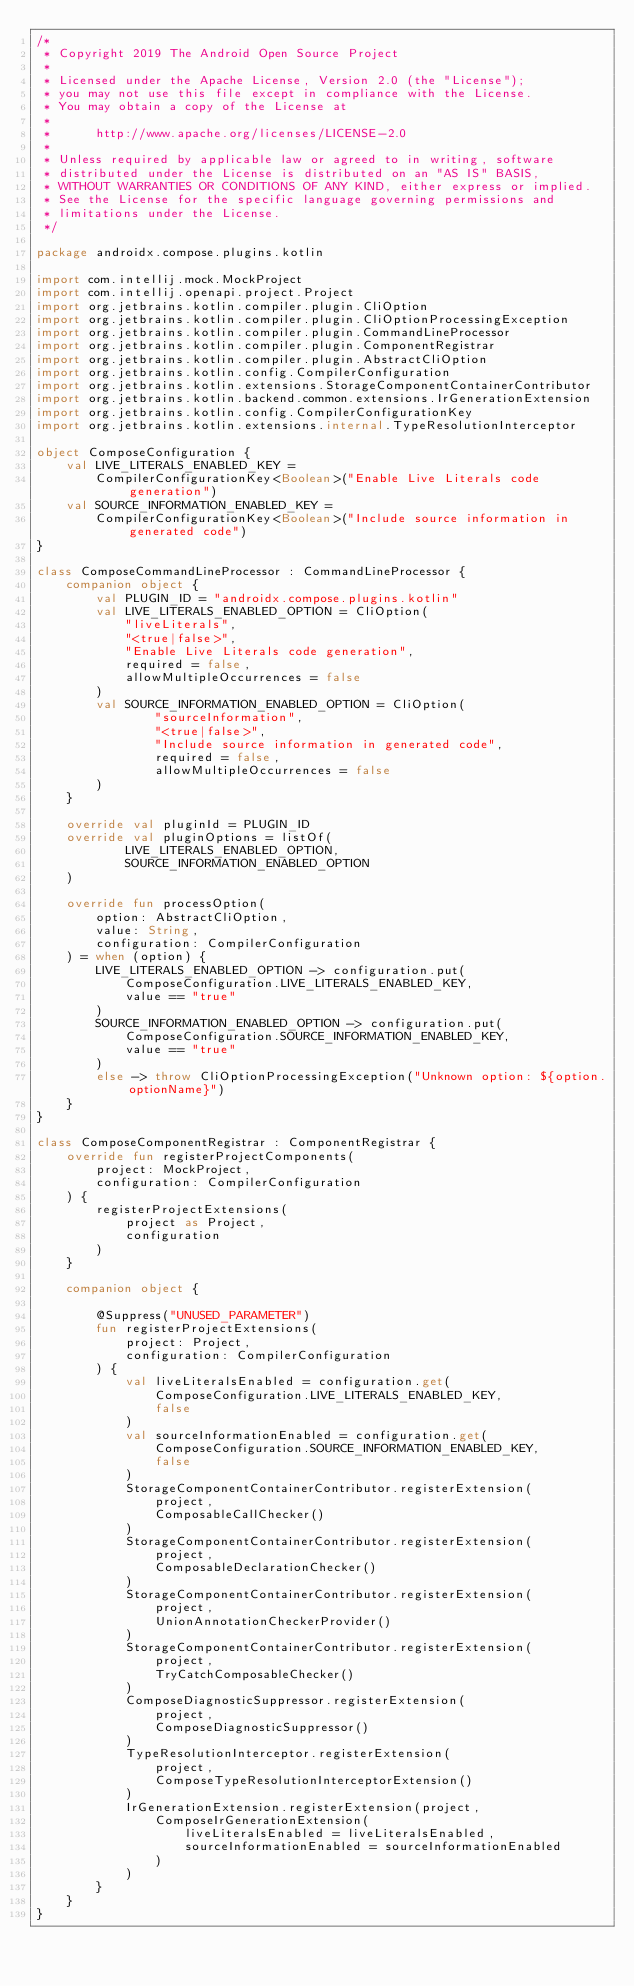<code> <loc_0><loc_0><loc_500><loc_500><_Kotlin_>/*
 * Copyright 2019 The Android Open Source Project
 *
 * Licensed under the Apache License, Version 2.0 (the "License");
 * you may not use this file except in compliance with the License.
 * You may obtain a copy of the License at
 *
 *      http://www.apache.org/licenses/LICENSE-2.0
 *
 * Unless required by applicable law or agreed to in writing, software
 * distributed under the License is distributed on an "AS IS" BASIS,
 * WITHOUT WARRANTIES OR CONDITIONS OF ANY KIND, either express or implied.
 * See the License for the specific language governing permissions and
 * limitations under the License.
 */

package androidx.compose.plugins.kotlin

import com.intellij.mock.MockProject
import com.intellij.openapi.project.Project
import org.jetbrains.kotlin.compiler.plugin.CliOption
import org.jetbrains.kotlin.compiler.plugin.CliOptionProcessingException
import org.jetbrains.kotlin.compiler.plugin.CommandLineProcessor
import org.jetbrains.kotlin.compiler.plugin.ComponentRegistrar
import org.jetbrains.kotlin.compiler.plugin.AbstractCliOption
import org.jetbrains.kotlin.config.CompilerConfiguration
import org.jetbrains.kotlin.extensions.StorageComponentContainerContributor
import org.jetbrains.kotlin.backend.common.extensions.IrGenerationExtension
import org.jetbrains.kotlin.config.CompilerConfigurationKey
import org.jetbrains.kotlin.extensions.internal.TypeResolutionInterceptor

object ComposeConfiguration {
    val LIVE_LITERALS_ENABLED_KEY =
        CompilerConfigurationKey<Boolean>("Enable Live Literals code generation")
    val SOURCE_INFORMATION_ENABLED_KEY =
        CompilerConfigurationKey<Boolean>("Include source information in generated code")
}

class ComposeCommandLineProcessor : CommandLineProcessor {
    companion object {
        val PLUGIN_ID = "androidx.compose.plugins.kotlin"
        val LIVE_LITERALS_ENABLED_OPTION = CliOption(
            "liveLiterals",
            "<true|false>",
            "Enable Live Literals code generation",
            required = false,
            allowMultipleOccurrences = false
        )
        val SOURCE_INFORMATION_ENABLED_OPTION = CliOption(
                "sourceInformation",
                "<true|false>",
                "Include source information in generated code",
                required = false,
                allowMultipleOccurrences = false
        )
    }

    override val pluginId = PLUGIN_ID
    override val pluginOptions = listOf(
            LIVE_LITERALS_ENABLED_OPTION,
            SOURCE_INFORMATION_ENABLED_OPTION
    )

    override fun processOption(
        option: AbstractCliOption,
        value: String,
        configuration: CompilerConfiguration
    ) = when (option) {
        LIVE_LITERALS_ENABLED_OPTION -> configuration.put(
            ComposeConfiguration.LIVE_LITERALS_ENABLED_KEY,
            value == "true"
        )
        SOURCE_INFORMATION_ENABLED_OPTION -> configuration.put(
            ComposeConfiguration.SOURCE_INFORMATION_ENABLED_KEY,
            value == "true"
        )
        else -> throw CliOptionProcessingException("Unknown option: ${option.optionName}")
    }
}

class ComposeComponentRegistrar : ComponentRegistrar {
    override fun registerProjectComponents(
        project: MockProject,
        configuration: CompilerConfiguration
    ) {
        registerProjectExtensions(
            project as Project,
            configuration
        )
    }

    companion object {

        @Suppress("UNUSED_PARAMETER")
        fun registerProjectExtensions(
            project: Project,
            configuration: CompilerConfiguration
        ) {
            val liveLiteralsEnabled = configuration.get(
                ComposeConfiguration.LIVE_LITERALS_ENABLED_KEY,
                false
            )
            val sourceInformationEnabled = configuration.get(
                ComposeConfiguration.SOURCE_INFORMATION_ENABLED_KEY,
                false
            )
            StorageComponentContainerContributor.registerExtension(
                project,
                ComposableCallChecker()
            )
            StorageComponentContainerContributor.registerExtension(
                project,
                ComposableDeclarationChecker()
            )
            StorageComponentContainerContributor.registerExtension(
                project,
                UnionAnnotationCheckerProvider()
            )
            StorageComponentContainerContributor.registerExtension(
                project,
                TryCatchComposableChecker()
            )
            ComposeDiagnosticSuppressor.registerExtension(
                project,
                ComposeDiagnosticSuppressor()
            )
            TypeResolutionInterceptor.registerExtension(
                project,
                ComposeTypeResolutionInterceptorExtension()
            )
            IrGenerationExtension.registerExtension(project,
                ComposeIrGenerationExtension(
                    liveLiteralsEnabled = liveLiteralsEnabled,
                    sourceInformationEnabled = sourceInformationEnabled
                )
            )
        }
    }
}
</code> 